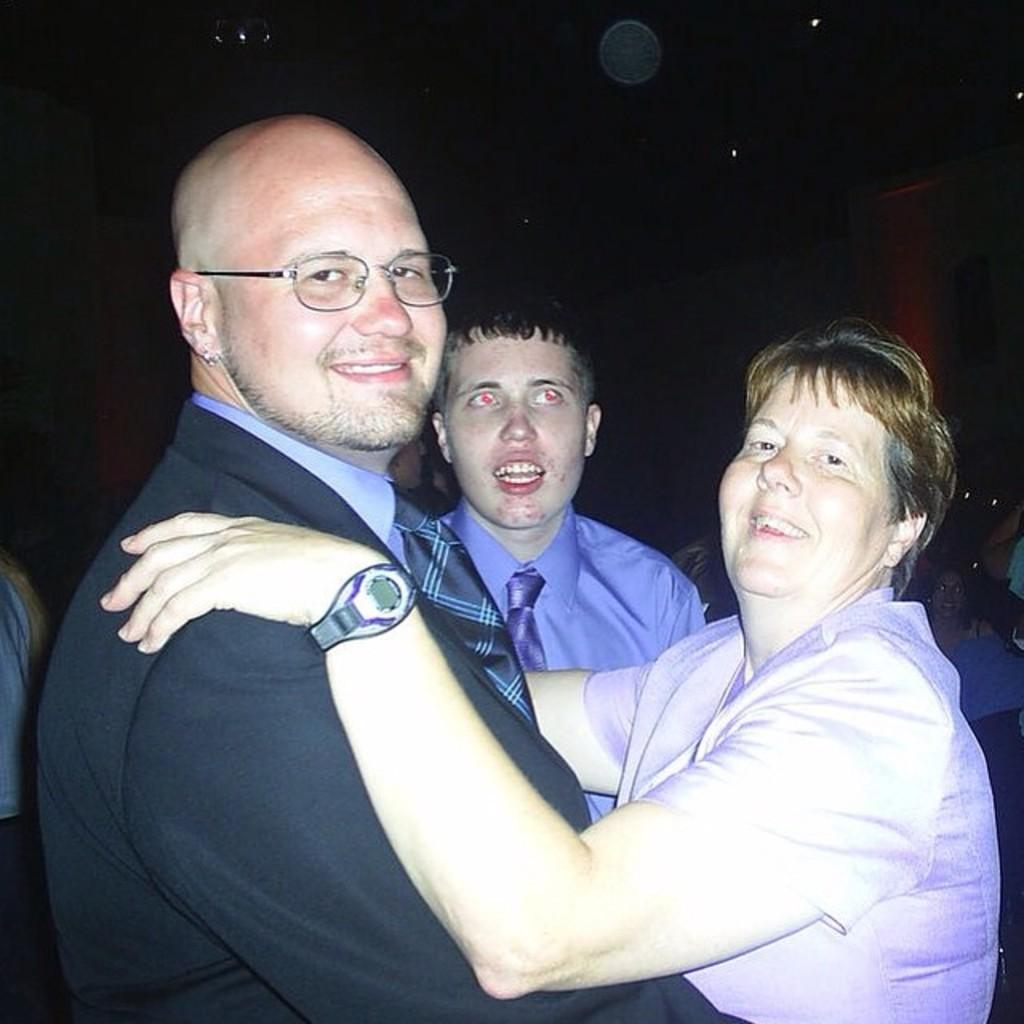How many people are in the image? There are three people in the image. What is the man in front wearing? The man in front is wearing a black coat and a blue shirt. What is the color of the background in the image? The background of the image is black in color. Is there any smoke visible in the image? No, there is no smoke present in the image. What type of room is shown in the image? The image does not show a room; it only features three people and a black background. 